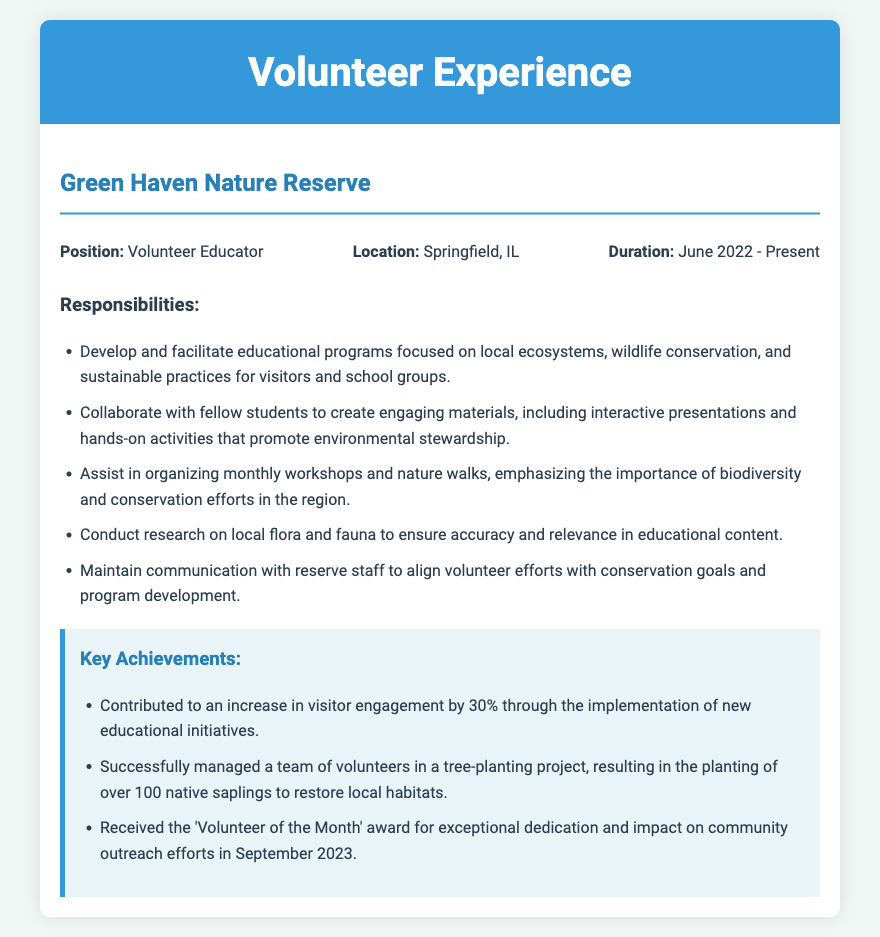What is the position held? The position specified in the document is "Volunteer Educator."
Answer: Volunteer Educator In which location is the Green Haven Nature Reserve situated? The document states that the reserve is located in "Springfield, IL."
Answer: Springfield, IL What is the duration of the volunteer experience? The duration mentioned in the document is "June 2022 - Present."
Answer: June 2022 - Present How much did visitor engagement increase? The document notes an increase in visitor engagement of "30%."
Answer: 30% What type of project did the volunteer successfully manage? The document states that the volunteer managed a "tree-planting project."
Answer: tree-planting project What award was received in September 2023? The document mentions the volunteer received the "Volunteer of the Month" award.
Answer: Volunteer of the Month What was one focus of the educational programs? The document indicates a focus on "local ecosystems."
Answer: local ecosystems How many native saplings were planted in the project? The document states that over "100 native saplings" were planted.
Answer: 100 native saplings Which aspect of conservation efforts was emphasized during workshops? The document specifies that the workshops emphasized "biodiversity."
Answer: biodiversity 